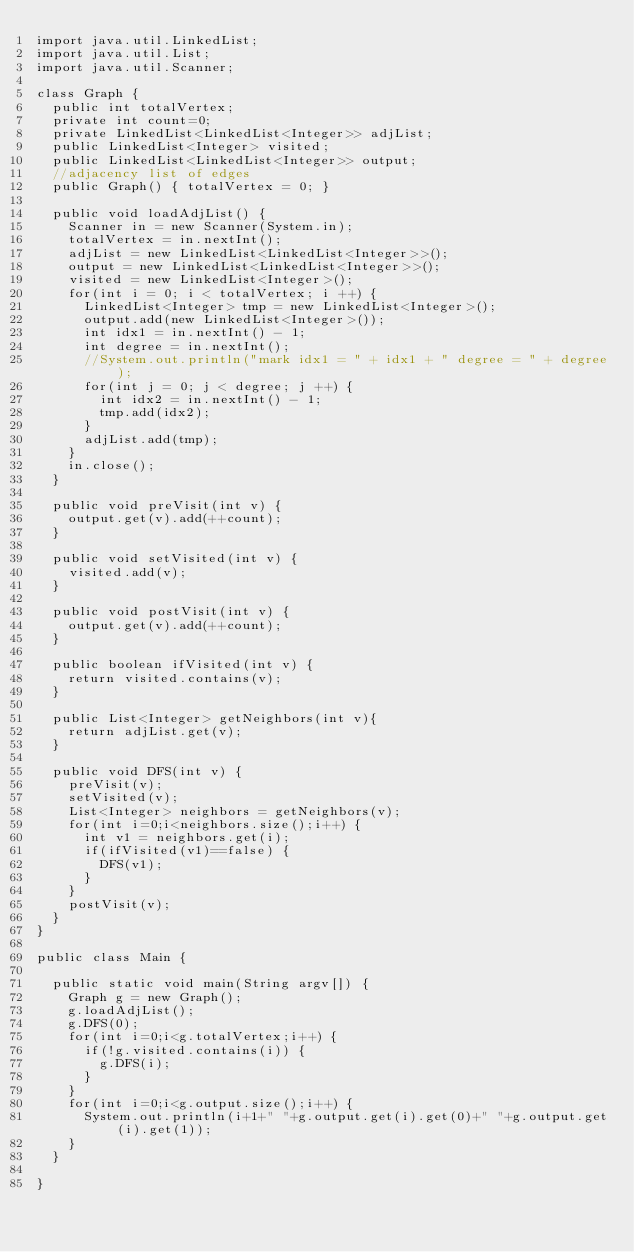<code> <loc_0><loc_0><loc_500><loc_500><_Java_>import java.util.LinkedList;
import java.util.List;
import java.util.Scanner;

class Graph {
	public int totalVertex;
	private int count=0;
	private LinkedList<LinkedList<Integer>> adjList;
	public LinkedList<Integer> visited;
	public LinkedList<LinkedList<Integer>> output;
	//adjacency list of edges
	public Graph() { totalVertex = 0; }
	
	public void loadAdjList() {
		Scanner in = new Scanner(System.in);
		totalVertex = in.nextInt();
		adjList = new LinkedList<LinkedList<Integer>>();
		output = new LinkedList<LinkedList<Integer>>();
		visited = new LinkedList<Integer>();
		for(int i = 0; i < totalVertex; i ++) {
			LinkedList<Integer> tmp = new LinkedList<Integer>();
			output.add(new LinkedList<Integer>());
			int idx1 = in.nextInt() - 1;
			int degree = in.nextInt();
			//System.out.println("mark idx1 = " + idx1 + " degree = " + degree);
			for(int j = 0; j < degree; j ++) {
				int idx2 = in.nextInt() - 1;
				tmp.add(idx2);
			}	
			adjList.add(tmp);
		}
		in.close();
	}
	
	public void preVisit(int v) {
		output.get(v).add(++count);
	}
	
	public void setVisited(int v) {
		visited.add(v);
	}
	
	public void postVisit(int v) {
		output.get(v).add(++count);
	}
	
	public boolean ifVisited(int v) {
		return visited.contains(v);
	}
	
	public List<Integer> getNeighbors(int v){
		return adjList.get(v);
	}

	public void DFS(int v) {
		preVisit(v);
		setVisited(v);
		List<Integer> neighbors = getNeighbors(v);
		for(int i=0;i<neighbors.size();i++) {
			int v1 = neighbors.get(i);
			if(ifVisited(v1)==false) {
				DFS(v1);
			}
		}
		postVisit(v);
	}
}

public class Main {

	public static void main(String argv[]) {
		Graph g = new Graph();
		g.loadAdjList();
		g.DFS(0);
		for(int i=0;i<g.totalVertex;i++) {
			if(!g.visited.contains(i)) {
				g.DFS(i);
			}
		}
		for(int i=0;i<g.output.size();i++) {
			System.out.println(i+1+" "+g.output.get(i).get(0)+" "+g.output.get(i).get(1));
		}
	}

}
</code> 